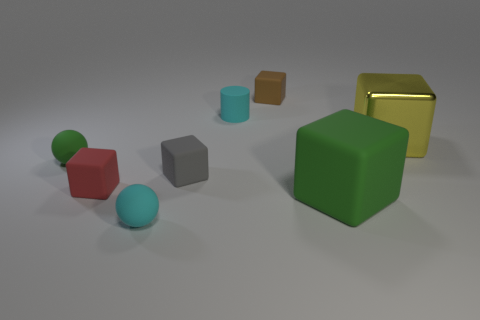Subtract all green cubes. How many cubes are left? 4 Subtract all green spheres. How many spheres are left? 1 Subtract 1 cylinders. How many cylinders are left? 0 Subtract all cylinders. How many objects are left? 7 Subtract all purple blocks. How many blue cylinders are left? 0 Add 1 big red rubber cylinders. How many objects exist? 9 Add 2 cyan objects. How many cyan objects are left? 4 Add 2 matte balls. How many matte balls exist? 4 Subtract 0 red cylinders. How many objects are left? 8 Subtract all green cylinders. Subtract all cyan spheres. How many cylinders are left? 1 